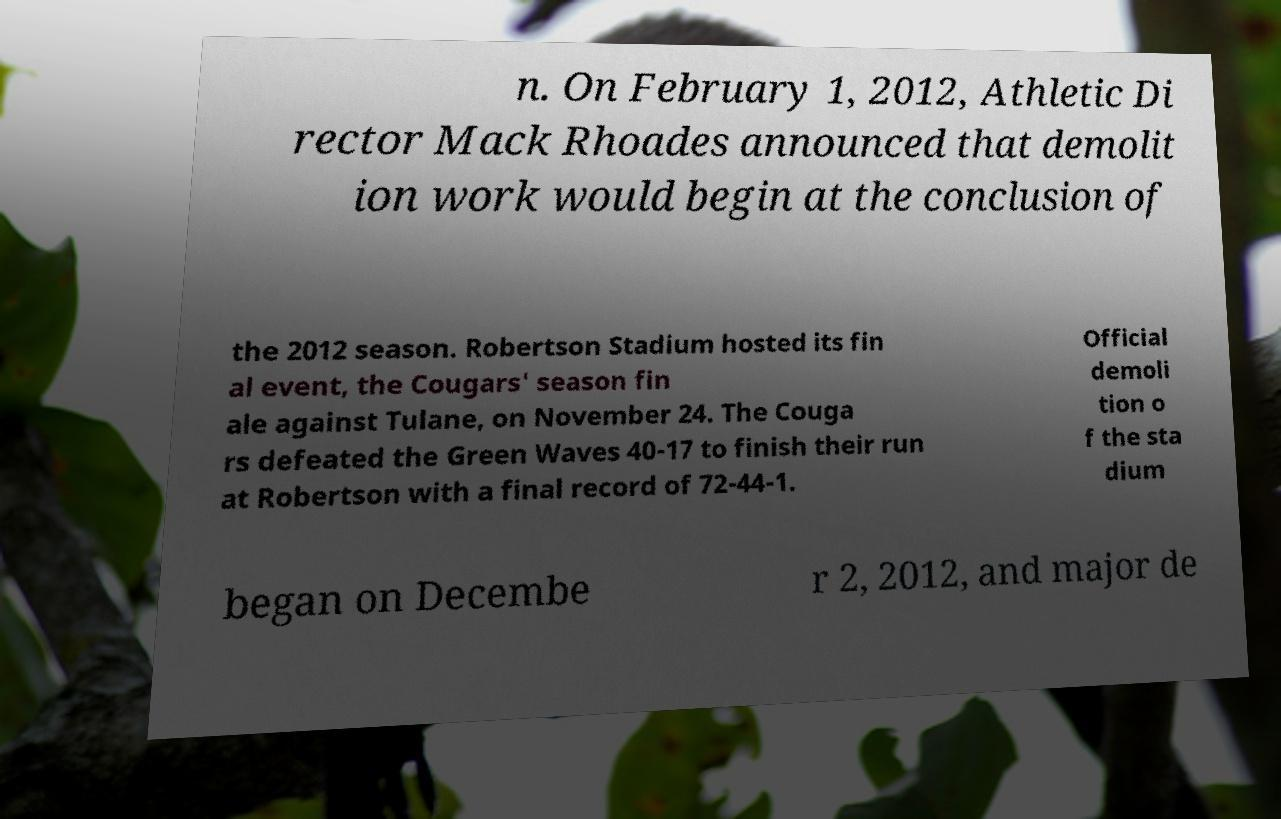There's text embedded in this image that I need extracted. Can you transcribe it verbatim? n. On February 1, 2012, Athletic Di rector Mack Rhoades announced that demolit ion work would begin at the conclusion of the 2012 season. Robertson Stadium hosted its fin al event, the Cougars' season fin ale against Tulane, on November 24. The Couga rs defeated the Green Waves 40-17 to finish their run at Robertson with a final record of 72-44-1. Official demoli tion o f the sta dium began on Decembe r 2, 2012, and major de 